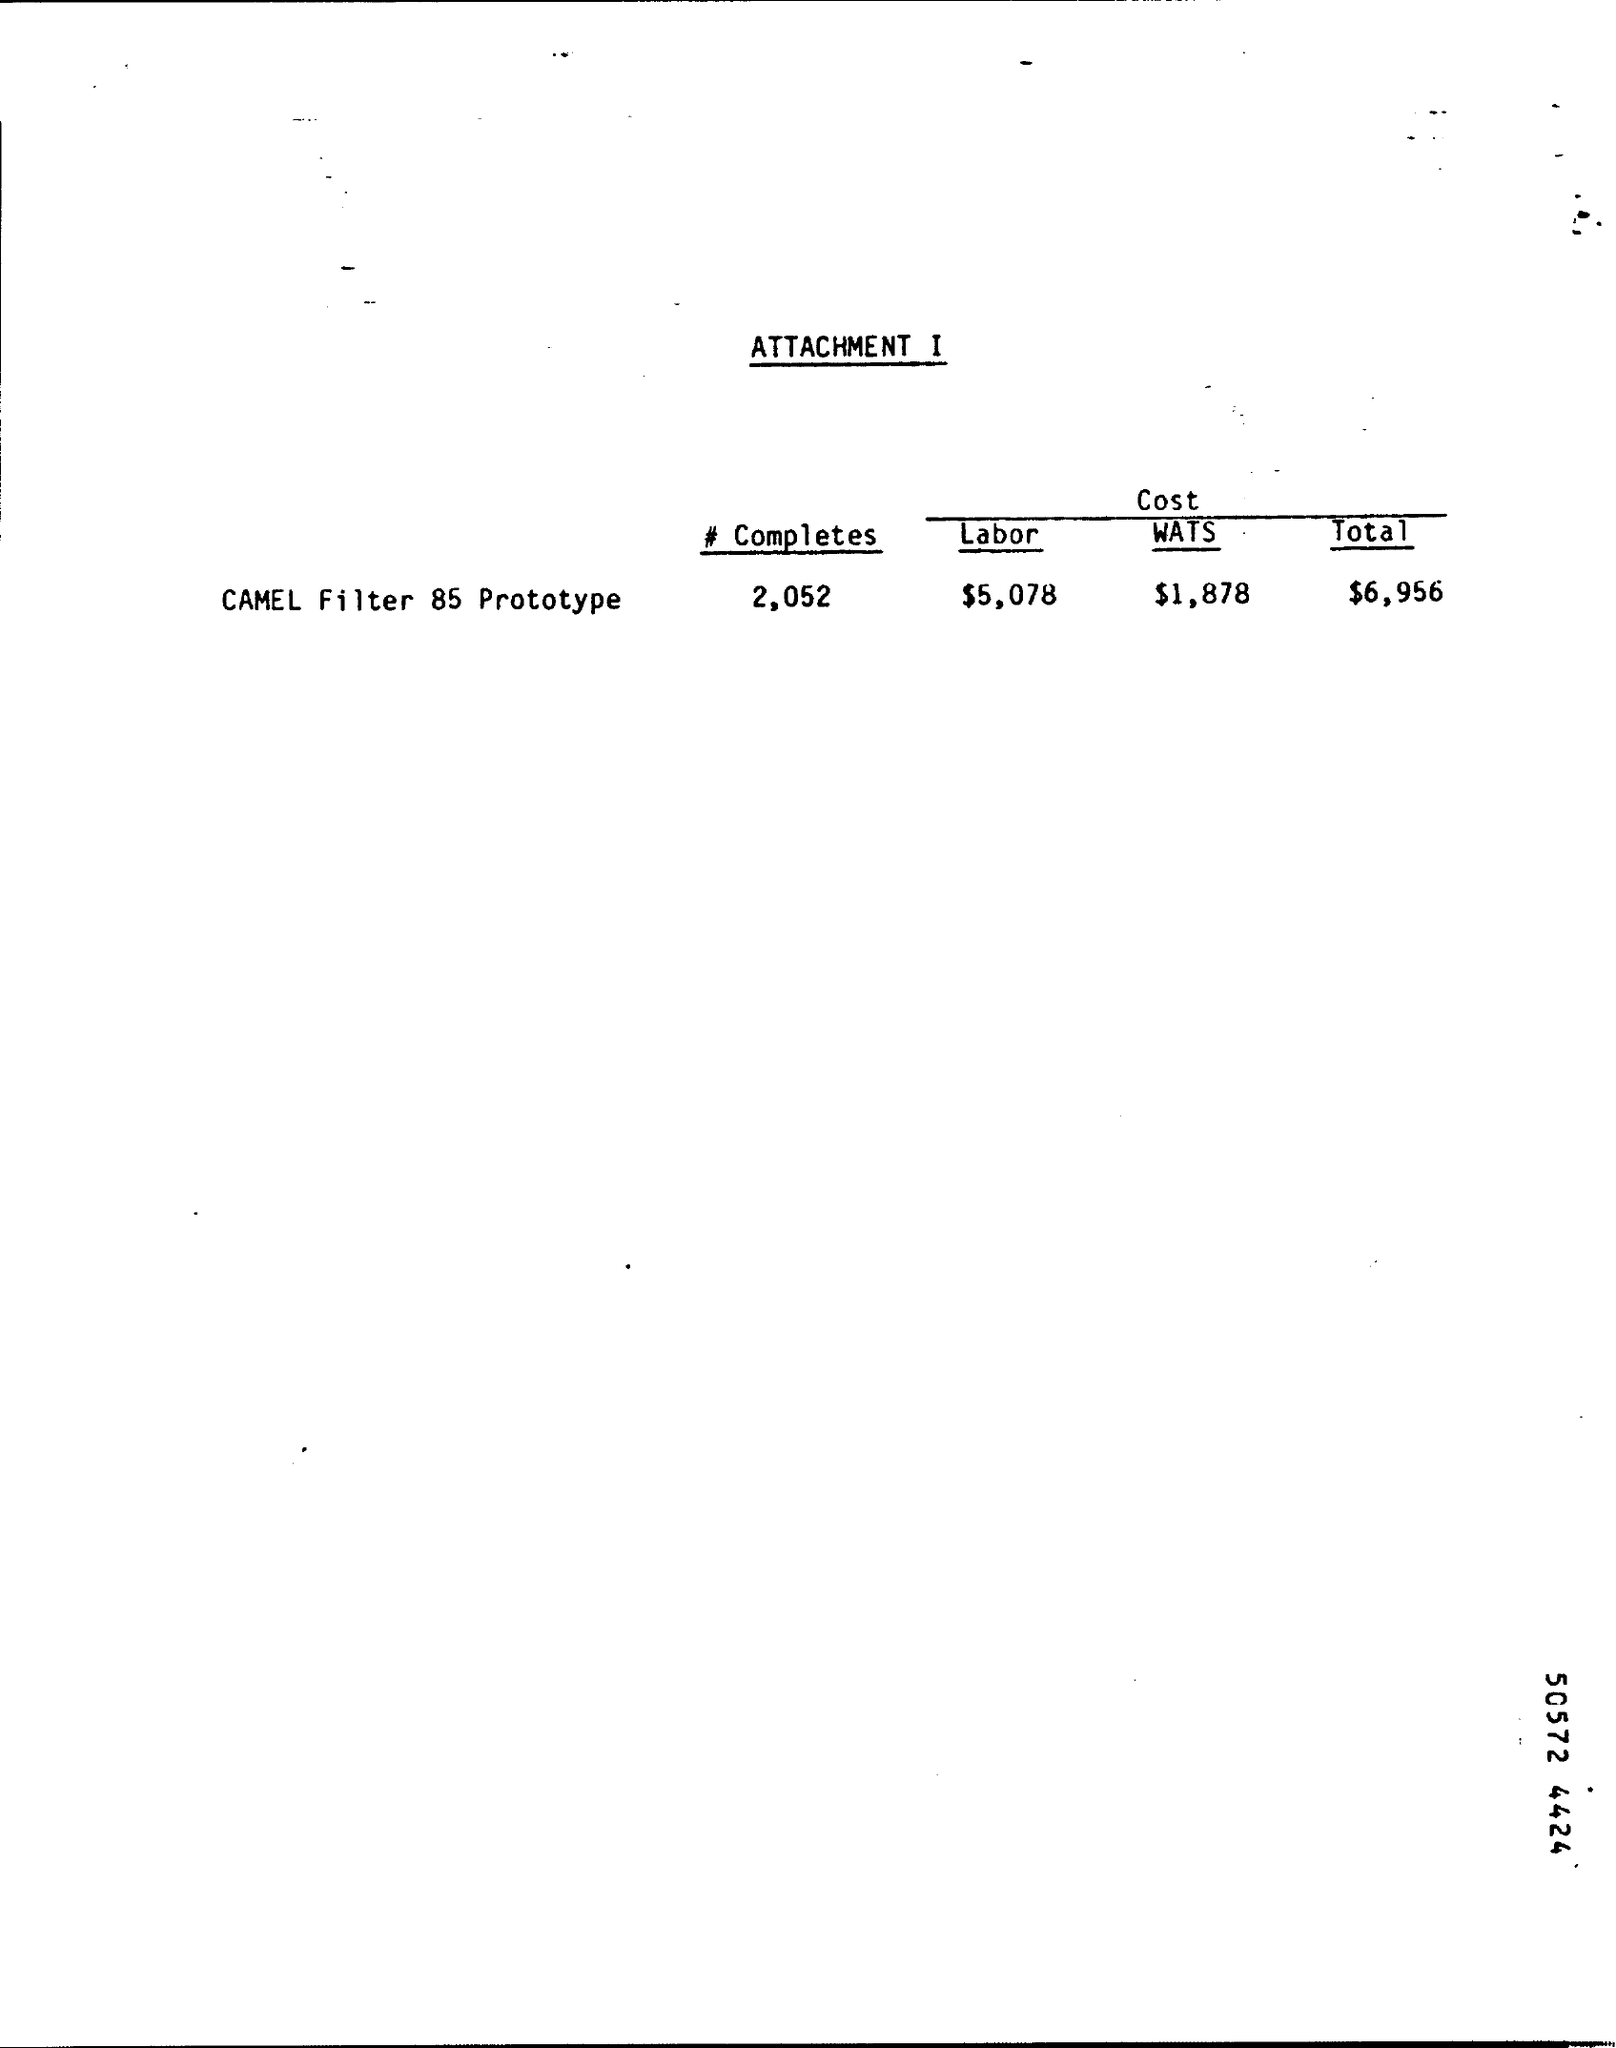What is the cost of the labor as mentioned in the attachment ?
Ensure brevity in your answer.  $5,078. What is the cost of wats for camel filter 85 prototype ?
Offer a terse response. $ 1,878. What is the total cost for camel filter 85 prototype ?
Give a very brief answer. $6,956. 